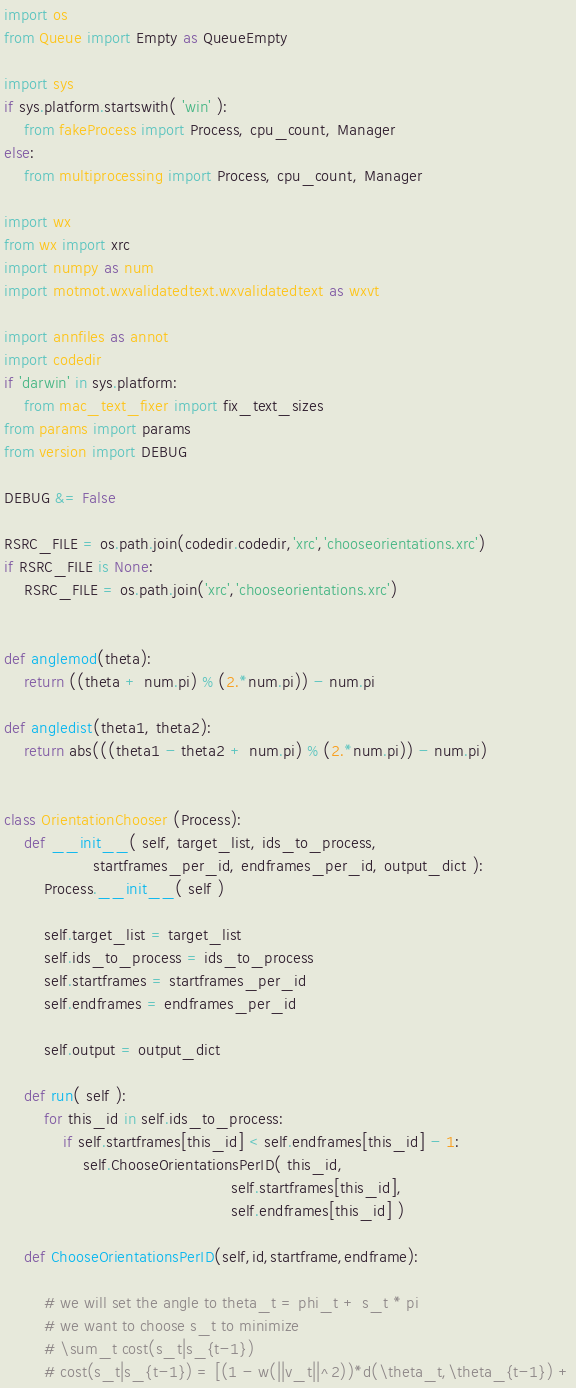<code> <loc_0><loc_0><loc_500><loc_500><_Python_>
import os
from Queue import Empty as QueueEmpty

import sys
if sys.platform.startswith( 'win' ):
    from fakeProcess import Process, cpu_count, Manager
else:
    from multiprocessing import Process, cpu_count, Manager

import wx
from wx import xrc
import numpy as num
import motmot.wxvalidatedtext.wxvalidatedtext as wxvt

import annfiles as annot
import codedir
if 'darwin' in sys.platform:
    from mac_text_fixer import fix_text_sizes
from params import params
from version import DEBUG

DEBUG &= False

RSRC_FILE = os.path.join(codedir.codedir,'xrc','chooseorientations.xrc')
if RSRC_FILE is None:
    RSRC_FILE = os.path.join('xrc','chooseorientations.xrc')


def anglemod(theta):
    return ((theta + num.pi) % (2.*num.pi)) - num.pi

def angledist(theta1, theta2):
    return abs(((theta1 - theta2 + num.pi) % (2.*num.pi)) - num.pi)


class OrientationChooser (Process):
    def __init__( self, target_list, ids_to_process,
                  startframes_per_id, endframes_per_id, output_dict ):
        Process.__init__( self )

        self.target_list = target_list
        self.ids_to_process = ids_to_process
        self.startframes = startframes_per_id
        self.endframes = endframes_per_id

        self.output = output_dict

    def run( self ):
        for this_id in self.ids_to_process:
            if self.startframes[this_id] < self.endframes[this_id] - 1:
                self.ChooseOrientationsPerID( this_id,
                                              self.startframes[this_id],
                                              self.endframes[this_id] )

    def ChooseOrientationsPerID(self,id,startframe,endframe):

        # we will set the angle to theta_t = phi_t + s_t * pi
        # we want to choose s_t to minimize
        # \sum_t cost(s_t|s_{t-1})
        # cost(s_t|s_{t-1}) = [(1 - w(||v_t||^2))*d(\theta_t,\theta_{t-1}) +</code> 